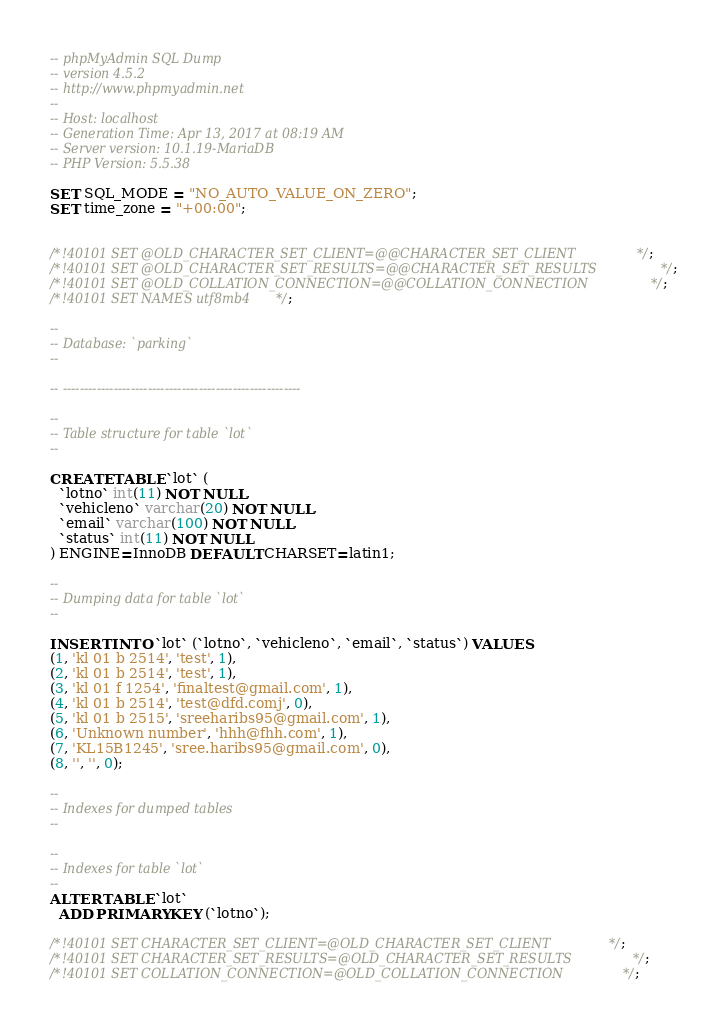<code> <loc_0><loc_0><loc_500><loc_500><_SQL_>-- phpMyAdmin SQL Dump
-- version 4.5.2
-- http://www.phpmyadmin.net
--
-- Host: localhost
-- Generation Time: Apr 13, 2017 at 08:19 AM
-- Server version: 10.1.19-MariaDB
-- PHP Version: 5.5.38

SET SQL_MODE = "NO_AUTO_VALUE_ON_ZERO";
SET time_zone = "+00:00";


/*!40101 SET @OLD_CHARACTER_SET_CLIENT=@@CHARACTER_SET_CLIENT */;
/*!40101 SET @OLD_CHARACTER_SET_RESULTS=@@CHARACTER_SET_RESULTS */;
/*!40101 SET @OLD_COLLATION_CONNECTION=@@COLLATION_CONNECTION */;
/*!40101 SET NAMES utf8mb4 */;

--
-- Database: `parking`
--

-- --------------------------------------------------------

--
-- Table structure for table `lot`
--

CREATE TABLE `lot` (
  `lotno` int(11) NOT NULL,
  `vehicleno` varchar(20) NOT NULL,
  `email` varchar(100) NOT NULL,
  `status` int(11) NOT NULL
) ENGINE=InnoDB DEFAULT CHARSET=latin1;

--
-- Dumping data for table `lot`
--

INSERT INTO `lot` (`lotno`, `vehicleno`, `email`, `status`) VALUES
(1, 'kl 01 b 2514', 'test', 1),
(2, 'kl 01 b 2514', 'test', 1),
(3, 'kl 01 f 1254', 'finaltest@gmail.com', 1),
(4, 'kl 01 b 2514', 'test@dfd.comj', 0),
(5, 'kl 01 b 2515', 'sreeharibs95@gmail.com', 1),
(6, 'Unknown number', 'hhh@fhh.com', 1),
(7, 'KL15B1245', 'sree.haribs95@gmail.com', 0),
(8, '', '', 0);

--
-- Indexes for dumped tables
--

--
-- Indexes for table `lot`
--
ALTER TABLE `lot`
  ADD PRIMARY KEY (`lotno`);

/*!40101 SET CHARACTER_SET_CLIENT=@OLD_CHARACTER_SET_CLIENT */;
/*!40101 SET CHARACTER_SET_RESULTS=@OLD_CHARACTER_SET_RESULTS */;
/*!40101 SET COLLATION_CONNECTION=@OLD_COLLATION_CONNECTION */;
</code> 